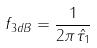<formula> <loc_0><loc_0><loc_500><loc_500>f _ { 3 d B } = \frac { 1 } { 2 \pi \hat { \tau _ { 1 } } }</formula> 